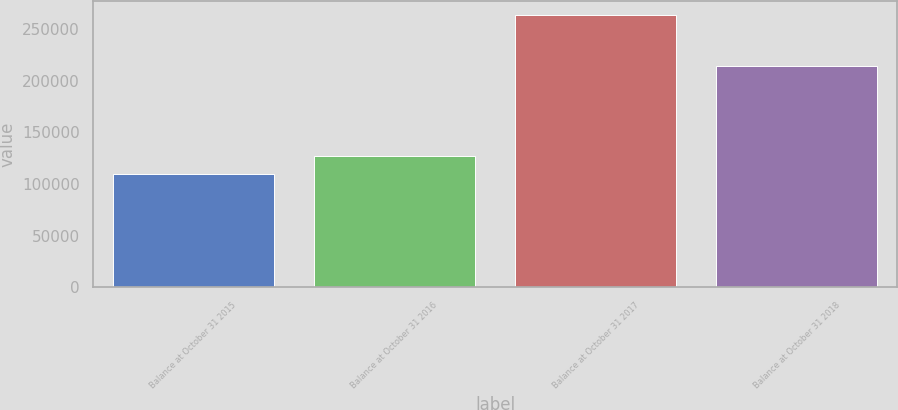<chart> <loc_0><loc_0><loc_500><loc_500><bar_chart><fcel>Balance at October 31 2015<fcel>Balance at October 31 2016<fcel>Balance at October 31 2017<fcel>Balance at October 31 2018<nl><fcel>109627<fcel>126850<fcel>263555<fcel>214432<nl></chart> 